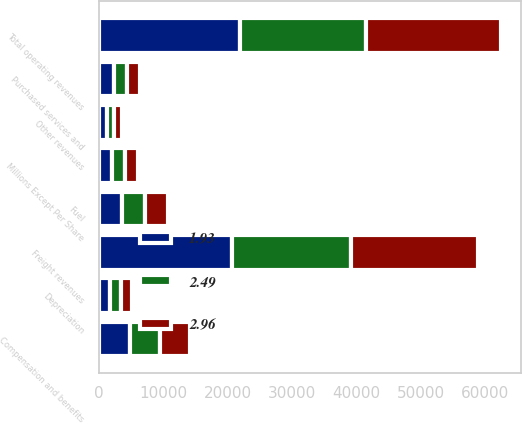<chart> <loc_0><loc_0><loc_500><loc_500><stacked_bar_chart><ecel><fcel>Millions Except Per Share<fcel>Freight revenues<fcel>Other revenues<fcel>Total operating revenues<fcel>Compensation and benefits<fcel>Fuel<fcel>Purchased services and<fcel>Depreciation<nl><fcel>1.93<fcel>2013<fcel>20684<fcel>1279<fcel>21963<fcel>4807<fcel>3534<fcel>2315<fcel>1777<nl><fcel>2.96<fcel>2012<fcel>19686<fcel>1240<fcel>20926<fcel>4685<fcel>3608<fcel>2143<fcel>1760<nl><fcel>2.49<fcel>2011<fcel>18508<fcel>1049<fcel>19557<fcel>4681<fcel>3581<fcel>2005<fcel>1617<nl></chart> 